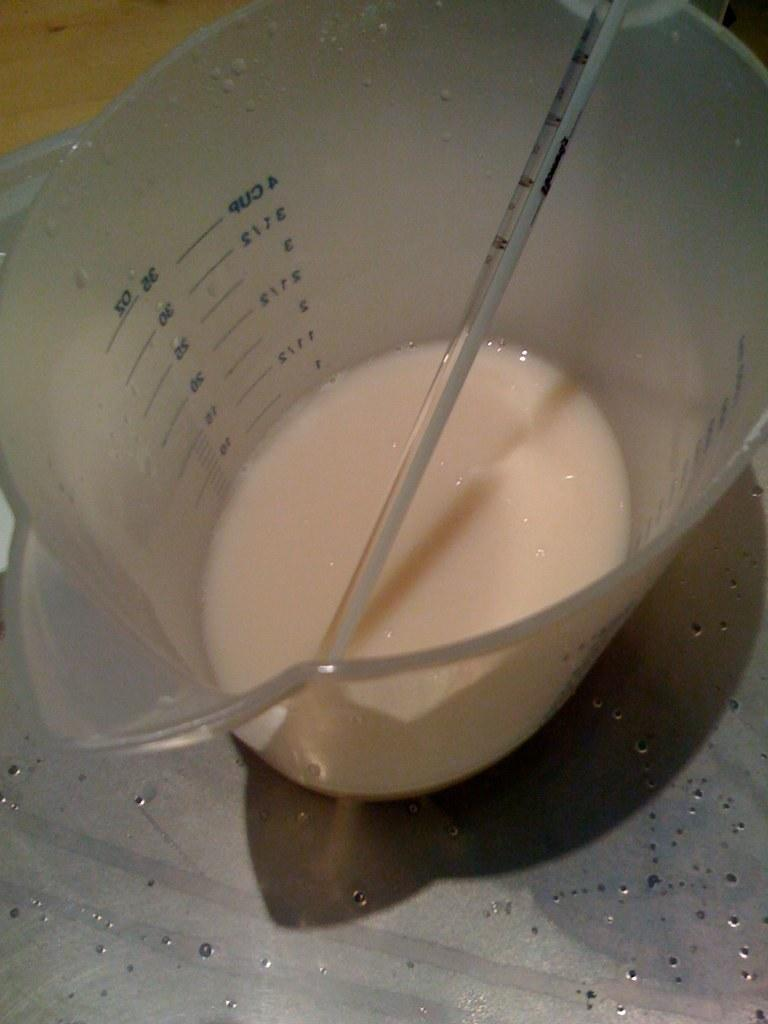What is inside the container in the image? The container has a drink in it. Is there any additional object inside the container? Yes, there is a thermometer in the container. What is the location of the container in the image? The container is on a table at the bottom of the image. How many babies are sitting under the tree in the image? There is no tree or babies present in the image. 